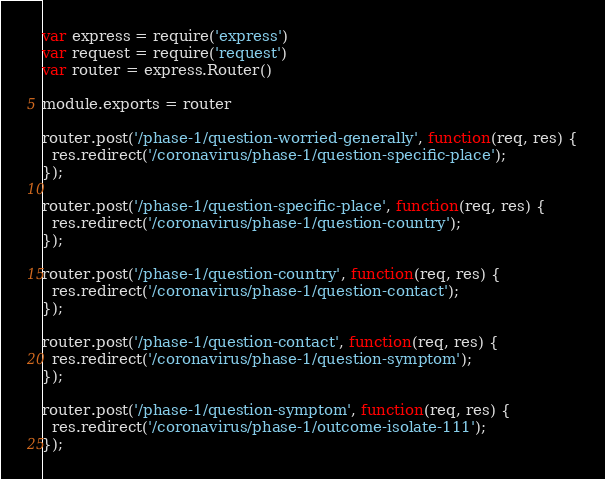<code> <loc_0><loc_0><loc_500><loc_500><_JavaScript_>var express = require('express')
var request = require('request')
var router = express.Router()

module.exports = router

router.post('/phase-1/question-worried-generally', function(req, res) {
  res.redirect('/coronavirus/phase-1/question-specific-place');
});

router.post('/phase-1/question-specific-place', function(req, res) {
  res.redirect('/coronavirus/phase-1/question-country');
});

router.post('/phase-1/question-country', function(req, res) {
  res.redirect('/coronavirus/phase-1/question-contact');
});

router.post('/phase-1/question-contact', function(req, res) {
  res.redirect('/coronavirus/phase-1/question-symptom');
});

router.post('/phase-1/question-symptom', function(req, res) {
  res.redirect('/coronavirus/phase-1/outcome-isolate-111');
});
</code> 